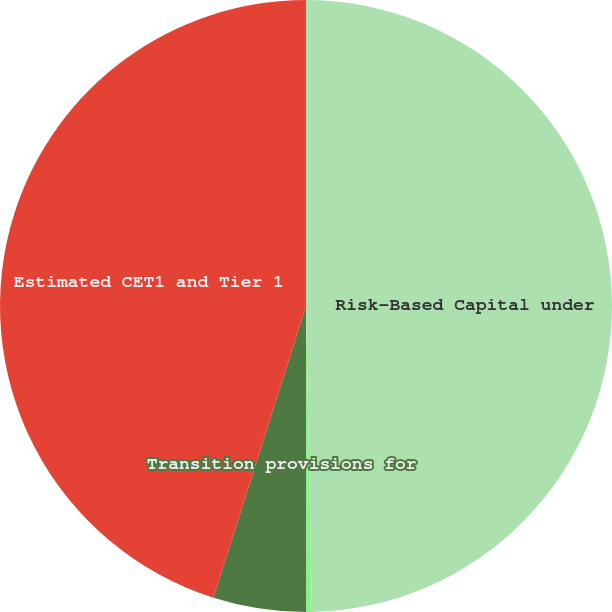Convert chart to OTSL. <chart><loc_0><loc_0><loc_500><loc_500><pie_chart><fcel>Risk-Based Capital under<fcel>AOCI<fcel>Transition provisions for<fcel>Estimated CET1 and Tier 1<nl><fcel>49.69%<fcel>0.31%<fcel>4.89%<fcel>45.11%<nl></chart> 